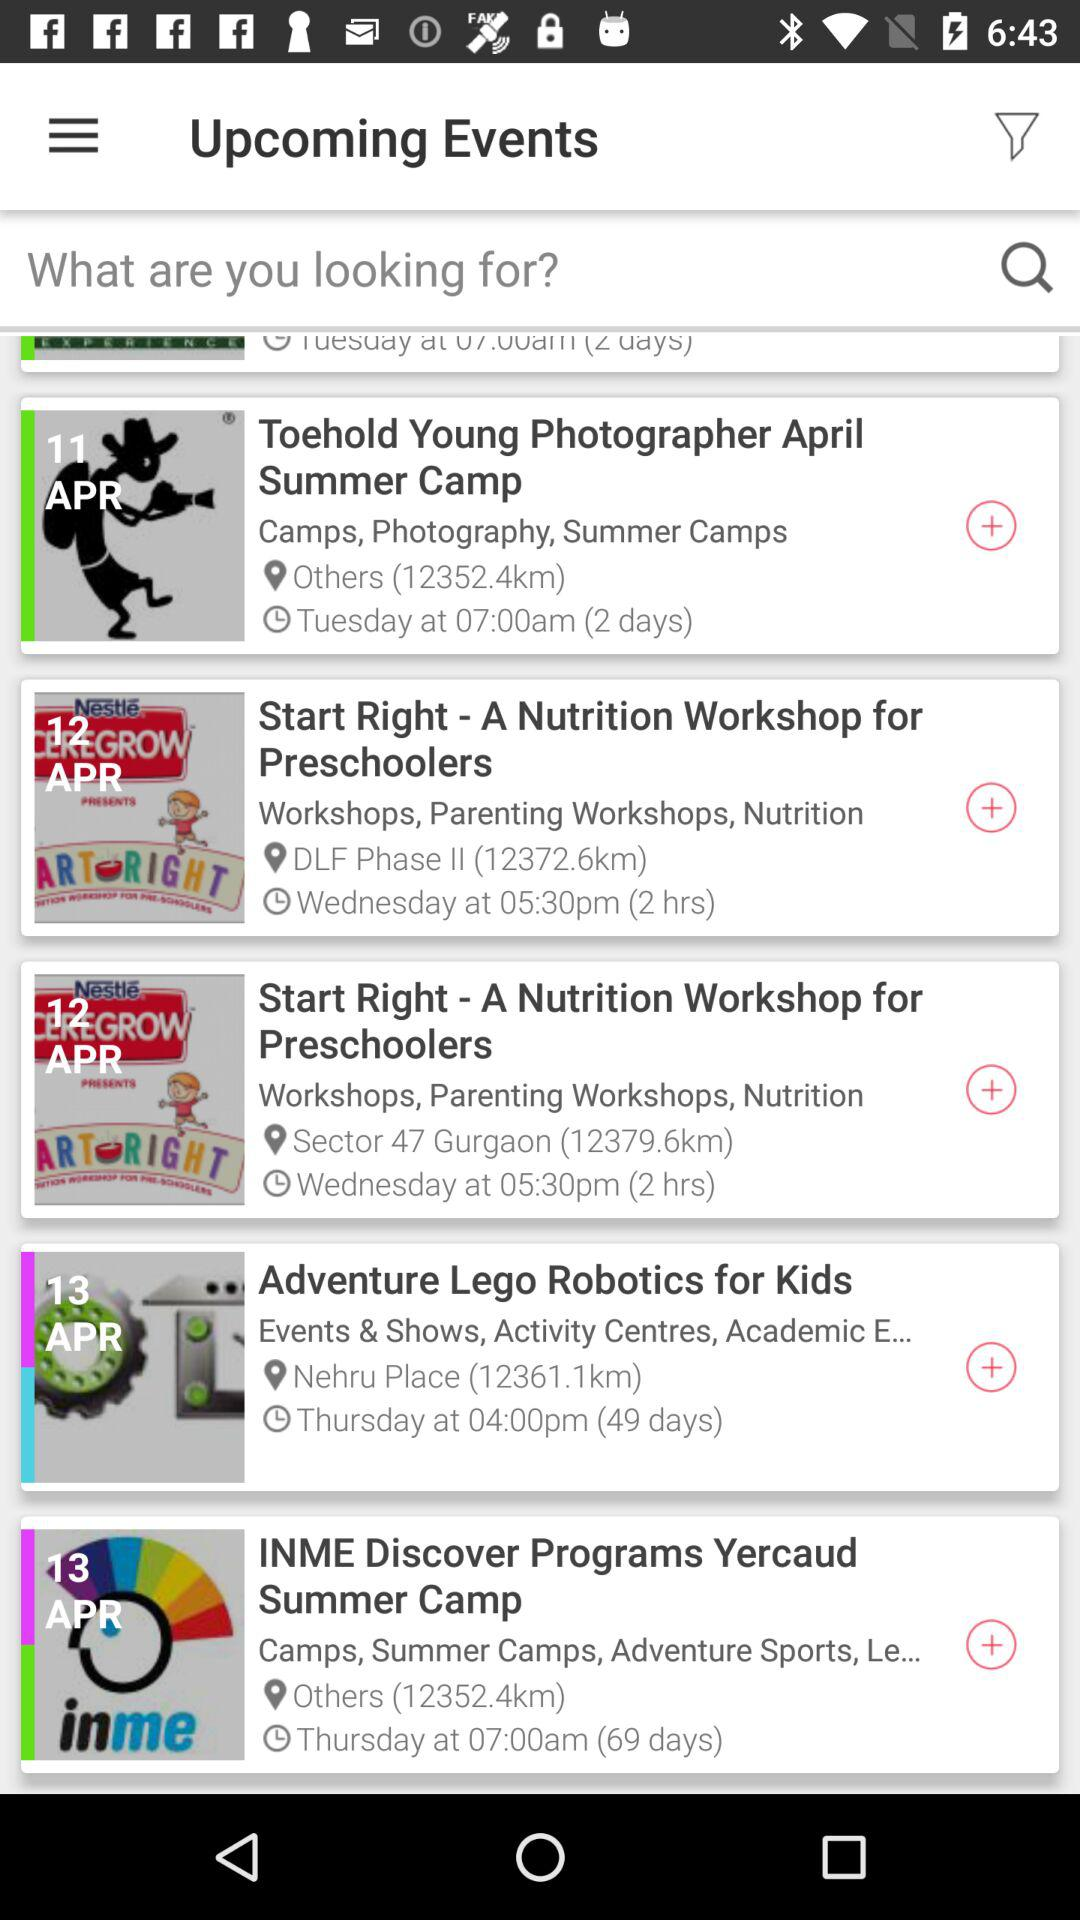What is the event date for "Toehold Young Photographer April Summer Camp"? The event date is April 11. 